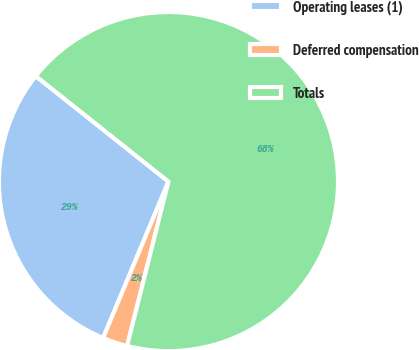Convert chart to OTSL. <chart><loc_0><loc_0><loc_500><loc_500><pie_chart><fcel>Operating leases (1)<fcel>Deferred compensation<fcel>Totals<nl><fcel>29.39%<fcel>2.38%<fcel>68.23%<nl></chart> 